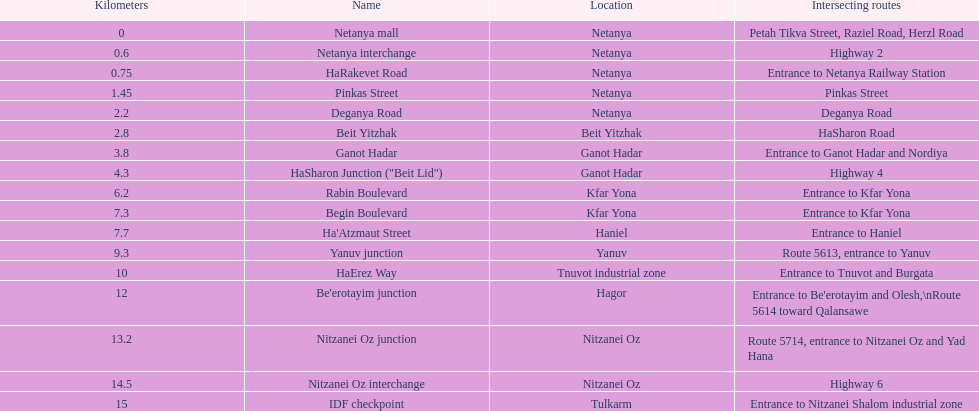Which portion has the same intersecting route as rabin boulevard? Begin Boulevard. 